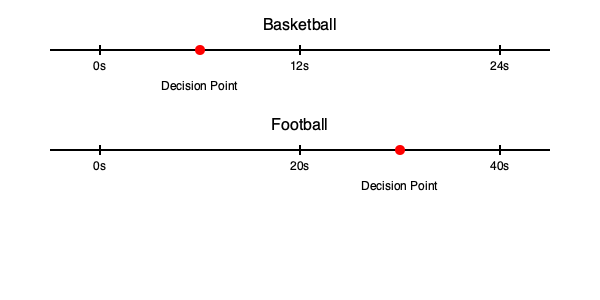Based on the timeline graphics for basketball and football, which sport requires faster decision-making on average? Explain your reasoning considering the shot clock in basketball and the play clock in football. To determine which sport requires faster decision-making on average, we need to analyze the time constraints in each sport as shown in the timeline graphics:

1. Basketball:
   - The shot clock is set to 24 seconds.
   - The decision point is marked at approximately 6 seconds into the possession.
   - This leaves about 18 seconds for the team to execute a play and attempt a shot.

2. Football:
   - The play clock is set to 40 seconds.
   - The decision point is marked at approximately 30 seconds into the play clock.
   - This leaves about 10 seconds for the team to set up and execute a play.

3. Comparison:
   - In basketball, players have 24 seconds total, with decisions often made within the first 6-12 seconds.
   - In football, players have 40 seconds total, with decisions typically made in the last 10-15 seconds.

4. Decision-making speed:
   - Basketball players must make decisions more frequently and with less overall time (24 seconds vs. 40 seconds).
   - The decision point in basketball comes earlier in the possession, indicating a need for quicker initial decision-making.

5. Continuous play factor:
   - Basketball involves continuous play, requiring constant decision-making throughout the 24-second shot clock.
   - Football has more stops between plays, allowing for more pre-play strategizing.

Given these factors, basketball requires faster decision-making on average due to the shorter overall time frame, earlier decision points, and the continuous nature of play.
Answer: Basketball requires faster decision-making on average. 